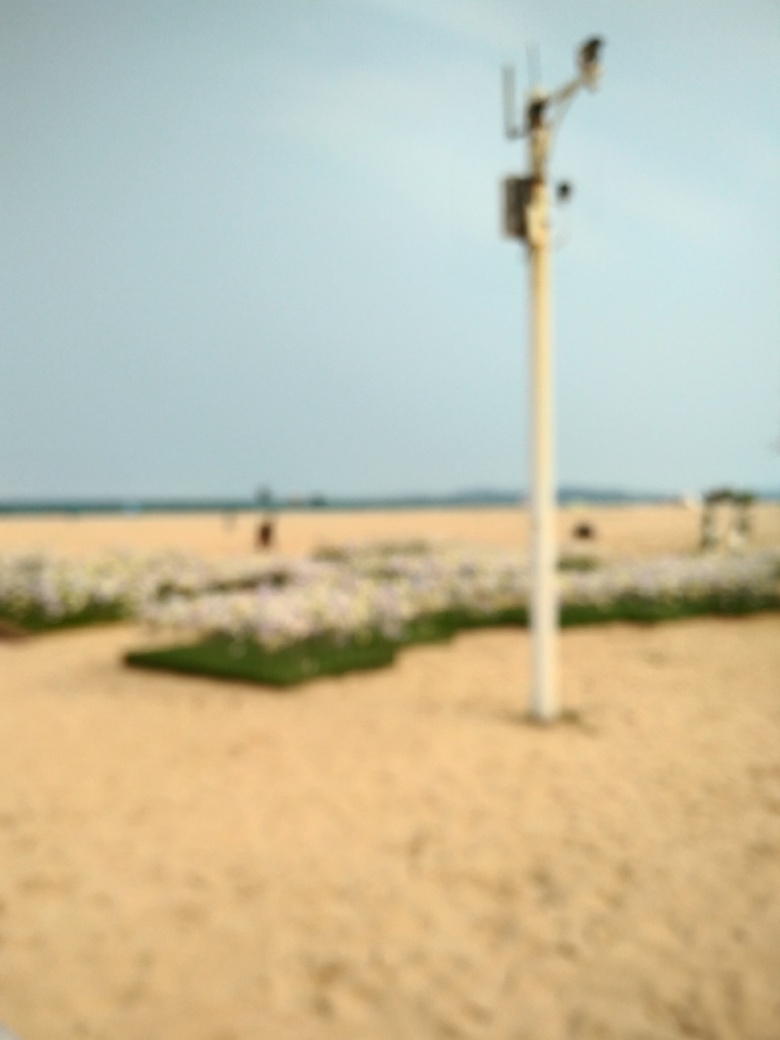Can you describe the general setting or environment depicted in this image? While precise details are difficult to discern due to the blur, the setting appears to be an expansive outdoor area, possibly a beach or a sandy park. There is a structure that might be a lamp post or some sort of pole with equipment attached to it in the foreground, and the background suggests an open sky and natural landscape. 